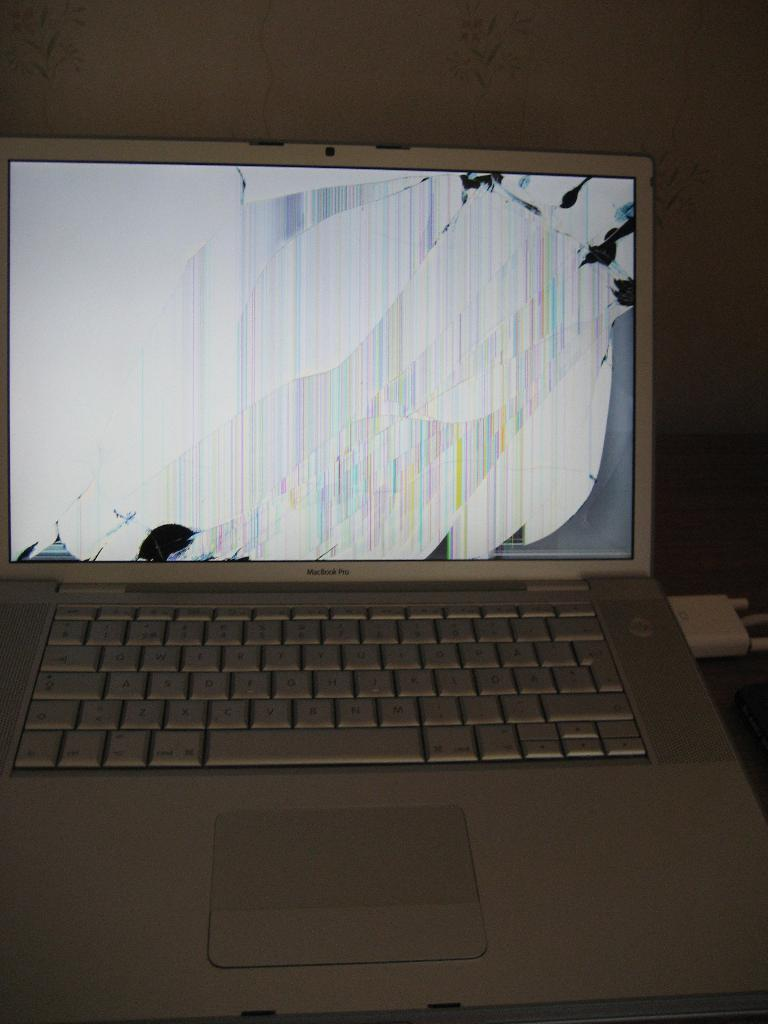<image>
Give a short and clear explanation of the subsequent image. A silver macbook pro with a broken screen. 